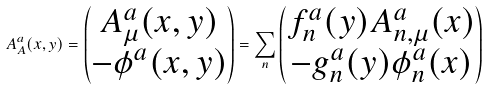<formula> <loc_0><loc_0><loc_500><loc_500>A ^ { a } _ { A } ( x , y ) = \begin{pmatrix} A ^ { a } _ { \mu } ( x , y ) \\ - \phi ^ { a } ( x , y ) \end{pmatrix} = \sum _ { n } \begin{pmatrix} f ^ { a } _ { n } ( y ) A ^ { a } _ { n , \mu } ( x ) \\ - g ^ { a } _ { n } ( y ) \phi ^ { a } _ { n } ( x ) \end{pmatrix}</formula> 